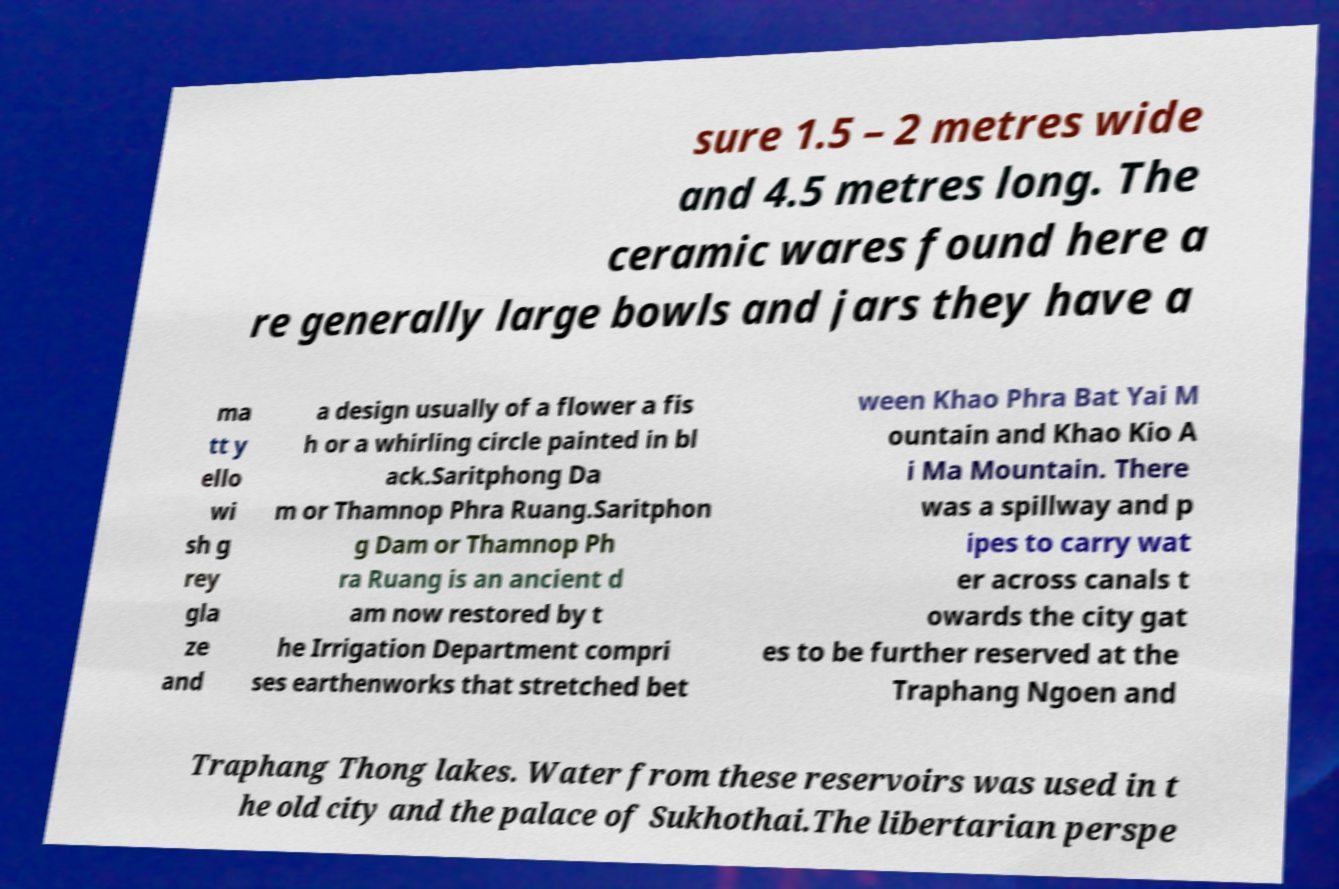Could you extract and type out the text from this image? sure 1.5 – 2 metres wide and 4.5 metres long. The ceramic wares found here a re generally large bowls and jars they have a ma tt y ello wi sh g rey gla ze and a design usually of a flower a fis h or a whirling circle painted in bl ack.Saritphong Da m or Thamnop Phra Ruang.Saritphon g Dam or Thamnop Ph ra Ruang is an ancient d am now restored by t he Irrigation Department compri ses earthenworks that stretched bet ween Khao Phra Bat Yai M ountain and Khao Kio A i Ma Mountain. There was a spillway and p ipes to carry wat er across canals t owards the city gat es to be further reserved at the Traphang Ngoen and Traphang Thong lakes. Water from these reservoirs was used in t he old city and the palace of Sukhothai.The libertarian perspe 